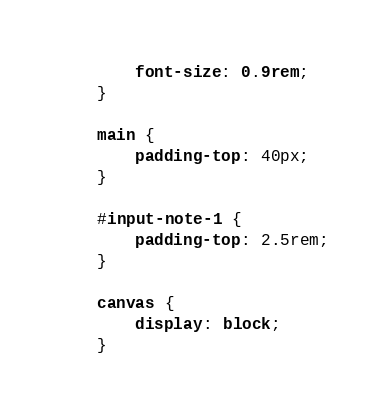<code> <loc_0><loc_0><loc_500><loc_500><_CSS_>    font-size: 0.9rem;
}

main {
    padding-top: 40px;
}

#input-note-1 {
    padding-top: 2.5rem;
}

canvas {
    display: block;
}</code> 